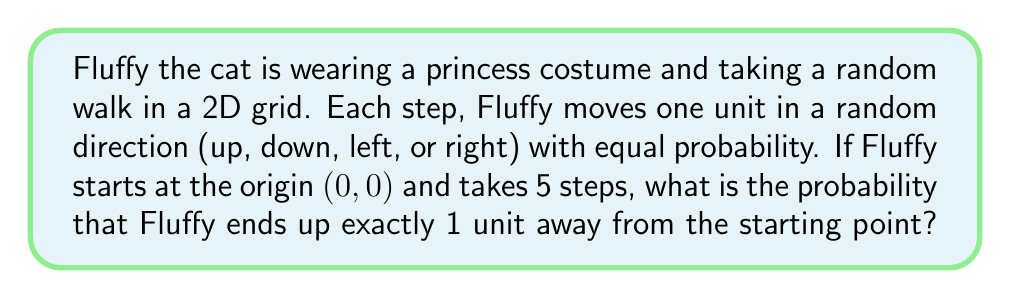Could you help me with this problem? Let's approach this step-by-step:

1) In a 2D random walk, the cat's position after $n$ steps can be described by two variables: $X$ (horizontal displacement) and $Y$ (vertical displacement).

2) After 5 steps, to be exactly 1 unit away from the origin, Fluffy must be at one of these positions: (1,0), (-1,0), (0,1), or (0,-1).

3) To reach any of these positions, Fluffy must have taken:
   - 3 steps in one direction and 2 steps in the perpendicular direction, or
   - 3 steps in one direction, 1 step in the opposite direction, and 1 step in a perpendicular direction

4) The probability of each specific path is $(\frac{1}{4})^5 = \frac{1}{1024}$, as each step has probability $\frac{1}{4}$.

5) Let's count the number of favorable paths:
   - For (1,0): $\binom{5}{3} = 10$ ways to choose 3 right steps, and $\binom{2}{1} = 2$ ways to distribute up/down steps
   - Same for (-1,0), (0,1), and (0,-1)

6) Total number of favorable paths: $4 * 10 * 2 = 80$

7) Therefore, the probability is:

   $$P(\text{1 unit away}) = 80 * \frac{1}{1024} = \frac{5}{64} = 0.078125$$
Answer: $\frac{5}{64}$ 